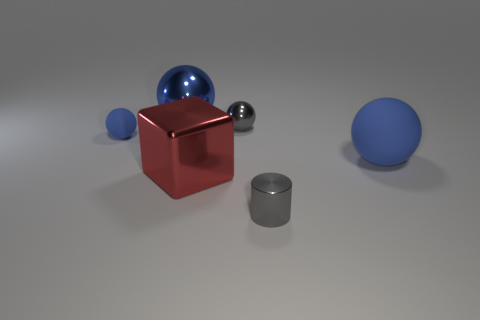Subtract all blue balls. How many were subtracted if there are1blue balls left? 2 Subtract all red cylinders. How many blue spheres are left? 3 Add 4 large blue matte balls. How many objects exist? 10 Subtract all cylinders. How many objects are left? 5 Add 4 red shiny cubes. How many red shiny cubes are left? 5 Add 2 big blue shiny objects. How many big blue shiny objects exist? 3 Subtract 0 yellow cylinders. How many objects are left? 6 Subtract all small gray balls. Subtract all big spheres. How many objects are left? 3 